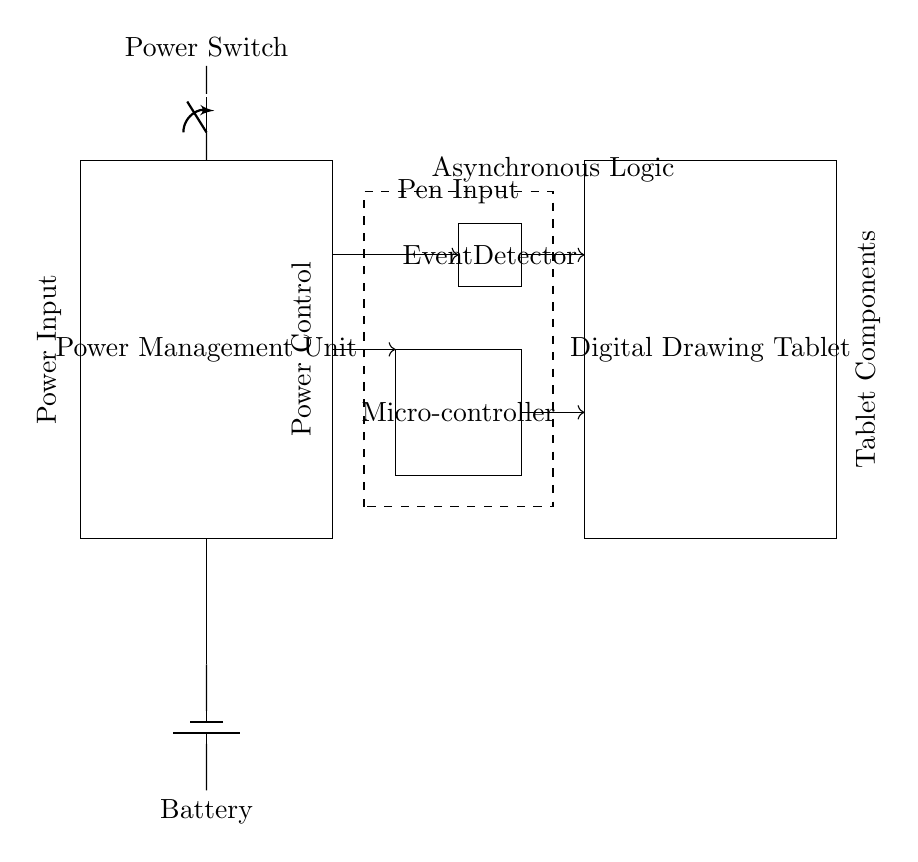What is the component that detects events? The Event Detector is located between the Microcontroller and Digital Drawing Tablet. It is responsible for detecting inputs and generating signals in response to events.
Answer: Event Detector What powers the circuit? The Battery, which is depicted as a rectangle with a plus and minus sign, provides the power for the entire system.
Answer: Battery How many main components are in this power management system? The main components include the Power Management Unit, Digital Drawing Tablet, Battery, Power Switch, Event Detector, and Microcontroller, totaling six main components.
Answer: Six What type of logic is indicated in the diagram? The circuit indicates the use of Asynchronous Logic, as denoted by the dashed rectangle surrounding the components related to event detection and control signals.
Answer: Asynchronous Logic Which component is responsible for controlling power? The Power Switch is responsible for controlling the power flow from the Battery to the rest of the circuit elements, enabling or disabling the power supply.
Answer: Power Switch What is the direction of current flow indicated in this diagram? The arrows in the diagram illustrate the direction of current flow, moving from the Battery through the Power Switch to the other components.
Answer: Downward Where is the Microcontroller located in this system? The Microcontroller is positioned between the Event Detector and other components, playing a crucial role in processing inputs and controlling signals within the system.
Answer: Between Event Detector and Digital Drawing Tablet 